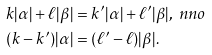Convert formula to latex. <formula><loc_0><loc_0><loc_500><loc_500>k | \alpha | + \ell | \beta | & = k ^ { \prime } | \alpha | + \ell ^ { \prime } | \beta | , \ n n o \\ ( k - k ^ { \prime } ) | \alpha | & = ( \ell ^ { \prime } - \ell ) | \beta | .</formula> 